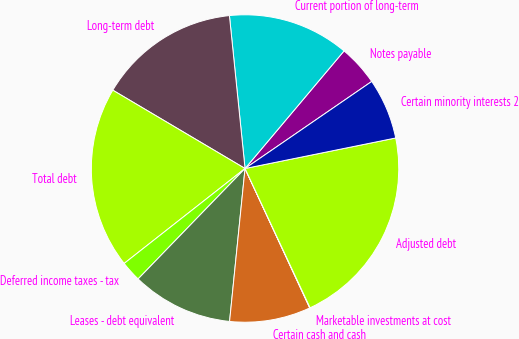<chart> <loc_0><loc_0><loc_500><loc_500><pie_chart><fcel>Notes payable<fcel>Current portion of long-term<fcel>Long-term debt<fcel>Total debt<fcel>Deferred income taxes - tax<fcel>Leases - debt equivalent<fcel>Certain cash and cash<fcel>Marketable investments at cost<fcel>Adjusted debt<fcel>Certain minority interests 2<nl><fcel>4.28%<fcel>12.76%<fcel>14.87%<fcel>19.11%<fcel>2.16%<fcel>10.64%<fcel>8.52%<fcel>0.04%<fcel>21.23%<fcel>6.4%<nl></chart> 